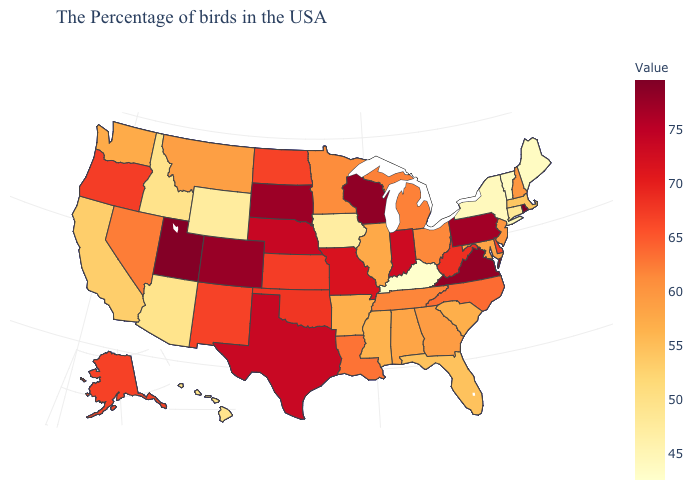Does Maryland have a higher value than Vermont?
Write a very short answer. Yes. Among the states that border Wyoming , which have the highest value?
Concise answer only. Utah. Among the states that border Arizona , which have the highest value?
Concise answer only. Utah. Does South Carolina have a higher value than Hawaii?
Give a very brief answer. Yes. Does Kentucky have the lowest value in the USA?
Write a very short answer. Yes. Among the states that border West Virginia , which have the lowest value?
Short answer required. Kentucky. 